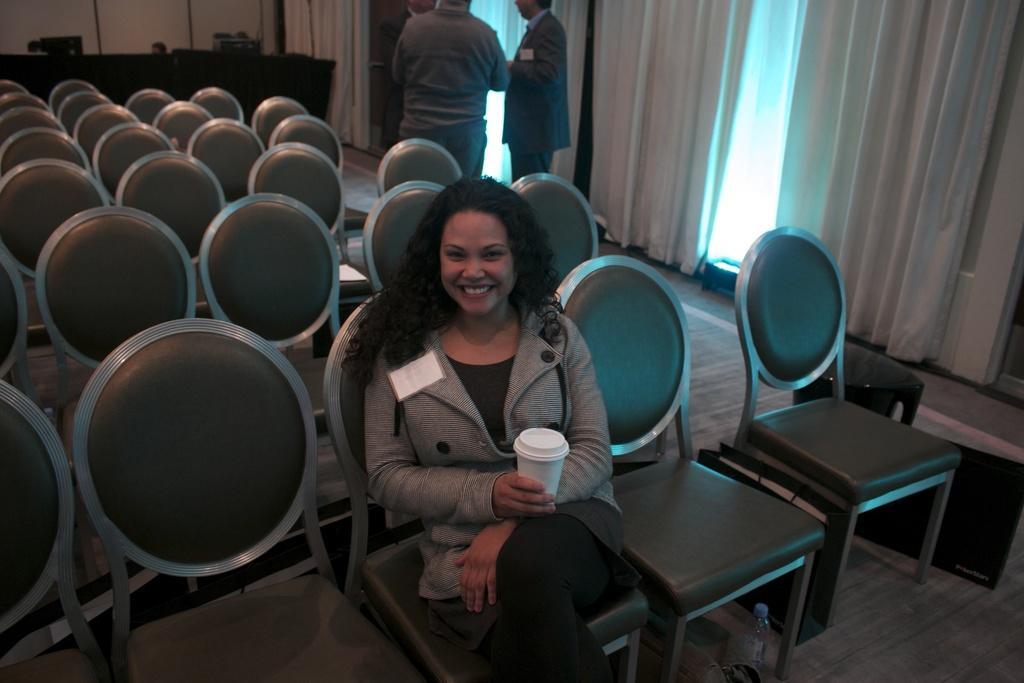How would you summarize this image in a sentence or two? in the picture a woman is sitting on chair catching a glass with her hands ,there are two persons back of woman. 